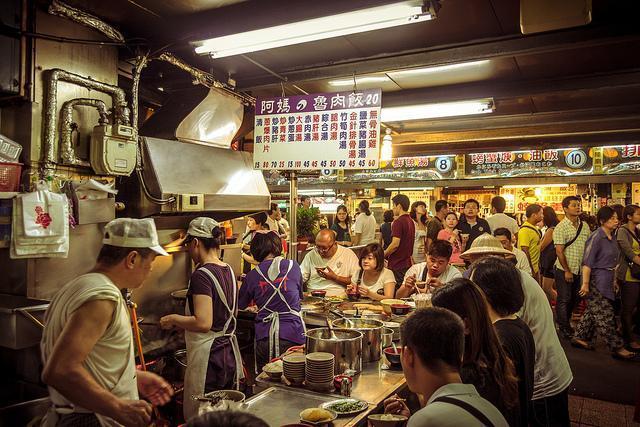How many people can be seen?
Give a very brief answer. 11. How many benches can be seen?
Give a very brief answer. 0. 